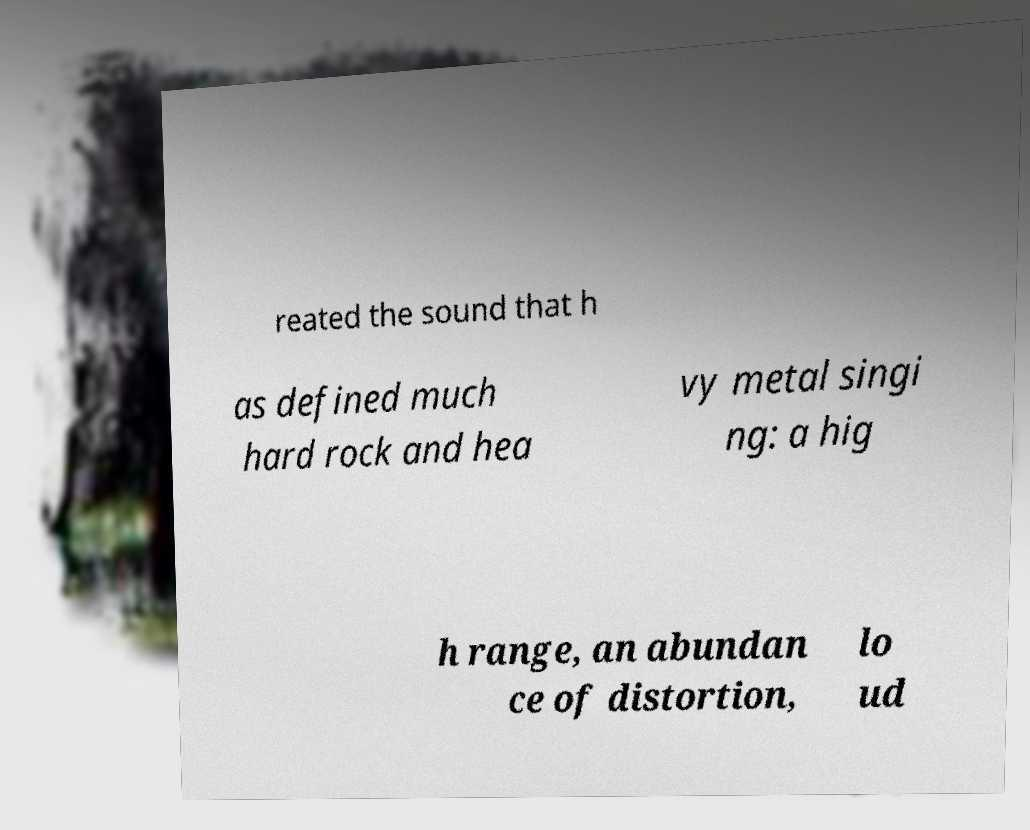Could you extract and type out the text from this image? reated the sound that h as defined much hard rock and hea vy metal singi ng: a hig h range, an abundan ce of distortion, lo ud 